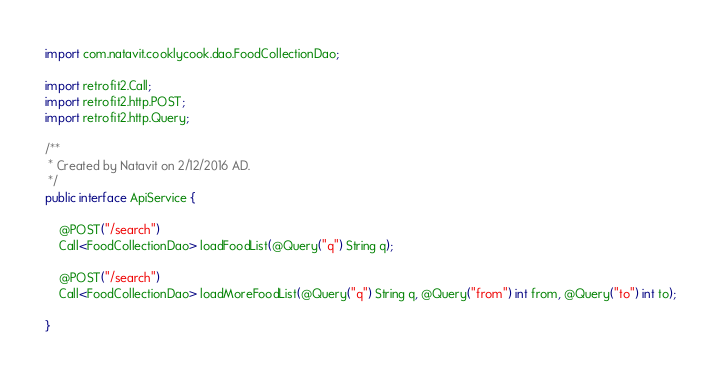<code> <loc_0><loc_0><loc_500><loc_500><_Java_>import com.natavit.cooklycook.dao.FoodCollectionDao;

import retrofit2.Call;
import retrofit2.http.POST;
import retrofit2.http.Query;

/**
 * Created by Natavit on 2/12/2016 AD.
 */
public interface ApiService {

    @POST("/search")
    Call<FoodCollectionDao> loadFoodList(@Query("q") String q);

    @POST("/search")
    Call<FoodCollectionDao> loadMoreFoodList(@Query("q") String q, @Query("from") int from, @Query("to") int to);

}
</code> 